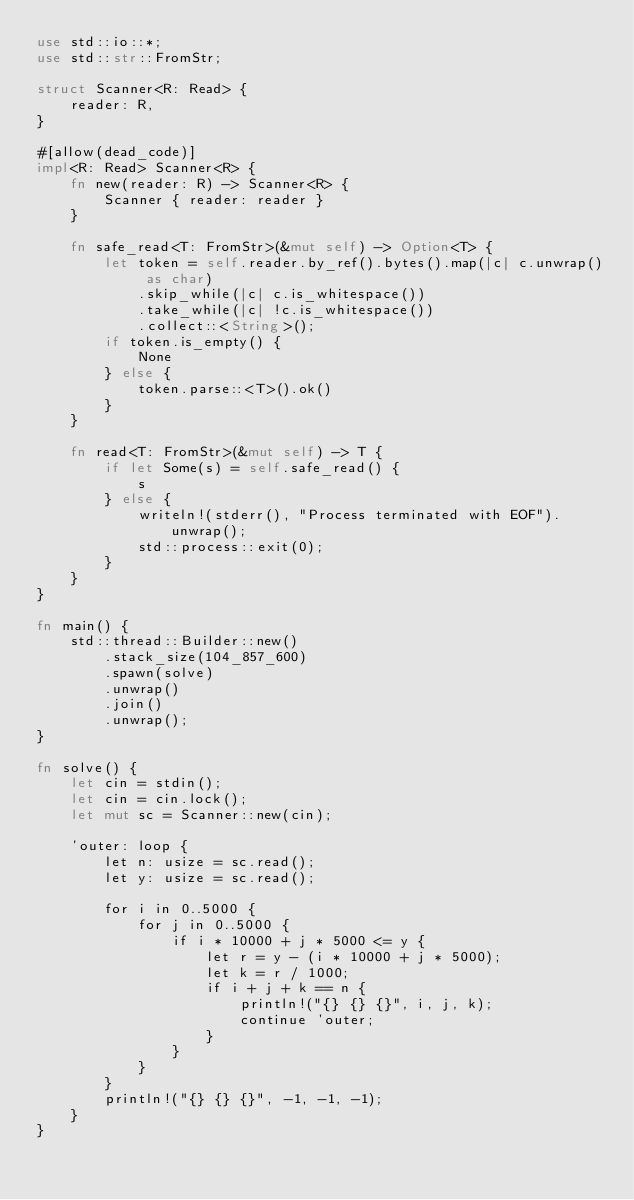Convert code to text. <code><loc_0><loc_0><loc_500><loc_500><_Rust_>use std::io::*;
use std::str::FromStr;

struct Scanner<R: Read> {
    reader: R,
}

#[allow(dead_code)]
impl<R: Read> Scanner<R> {
    fn new(reader: R) -> Scanner<R> {
        Scanner { reader: reader }
    }

    fn safe_read<T: FromStr>(&mut self) -> Option<T> {
        let token = self.reader.by_ref().bytes().map(|c| c.unwrap() as char)
            .skip_while(|c| c.is_whitespace())
            .take_while(|c| !c.is_whitespace())
            .collect::<String>();
        if token.is_empty() {
            None
        } else {
            token.parse::<T>().ok()
        }
    }

    fn read<T: FromStr>(&mut self) -> T {
        if let Some(s) = self.safe_read() {
            s
        } else {
            writeln!(stderr(), "Process terminated with EOF").unwrap();
            std::process::exit(0);
        }
    }
}

fn main() {
    std::thread::Builder::new()
        .stack_size(104_857_600)
        .spawn(solve)
        .unwrap()
        .join()
        .unwrap();
}

fn solve() {
    let cin = stdin();
    let cin = cin.lock();
    let mut sc = Scanner::new(cin);

    'outer: loop {
        let n: usize = sc.read();
        let y: usize = sc.read();

        for i in 0..5000 {
            for j in 0..5000 {
                if i * 10000 + j * 5000 <= y {
                    let r = y - (i * 10000 + j * 5000);
                    let k = r / 1000;
                    if i + j + k == n {
                        println!("{} {} {}", i, j, k);
                        continue 'outer;
                    }
                }
            }
        }
        println!("{} {} {}", -1, -1, -1);
    }
}
</code> 